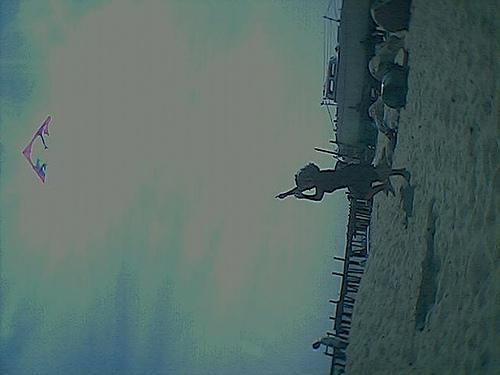How many kites are on air?
Give a very brief answer. 1. How many black cars are there?
Give a very brief answer. 0. 